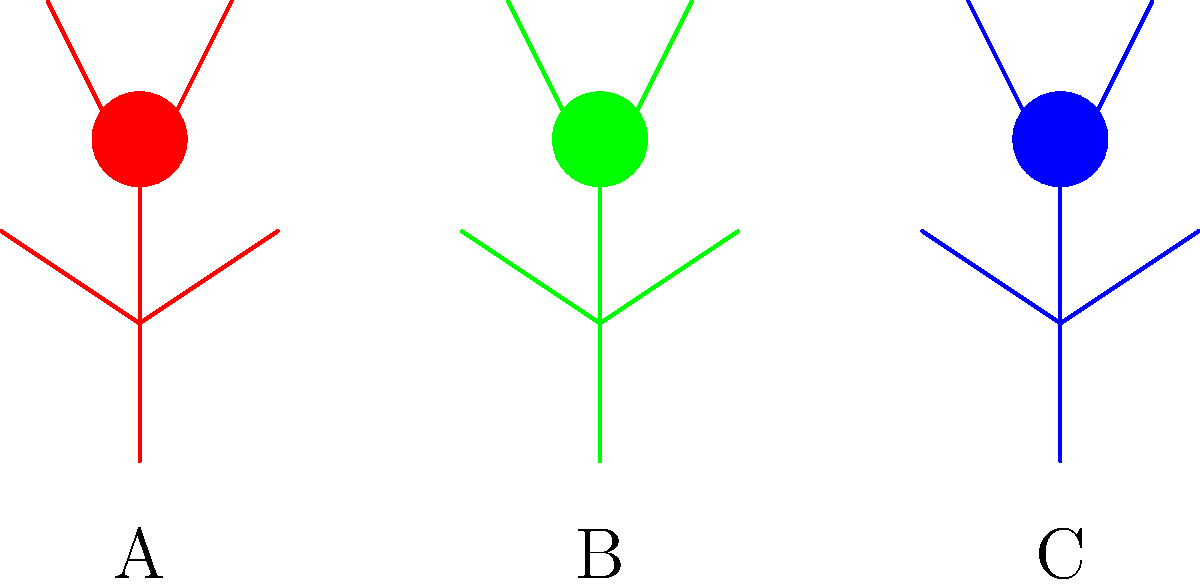In the caricature above, three political leaders (A, B, and C) are depicted with different postures. Which leader's posture suggests the highest level of confidence based on biomechanical principles of body language? To answer this question, we need to analyze the biomechanical aspects of each figure's posture:

1. Figure A (red):
   - Straight, upright posture
   - Arms and legs symmetrically positioned
   - Head aligned with the spine

2. Figure B (green):
   - Slightly leaning backwards
   - Arms and legs asymmetrically positioned
   - Head tilted slightly back

3. Figure C (blue):
   - Leaning slightly forward
   - Arms and legs asymmetrically positioned
   - Head tilted slightly forward

Biomechanical principles of body language suggest:

1. An upright posture with a straight spine indicates confidence and openness.
2. Symmetry in body positioning suggests balance and control.
3. A forward lean can indicate engagement and assertiveness, but too much can appear aggressive.
4. A backward lean can suggest relaxation or arrogance, depending on the context.

Based on these principles, Figure A demonstrates the most confident posture:
- The straight, upright stance shows a strong, stable core and projects authority.
- The symmetrical positioning of arms and legs suggests balance and control.
- The aligned head position indicates attentiveness and engagement without appearing aggressive or arrogant.

While Figures B and C show some confident elements, their asymmetry and tilted postures are less indicative of overall confidence compared to Figure A's balanced and upright stance.
Answer: A 